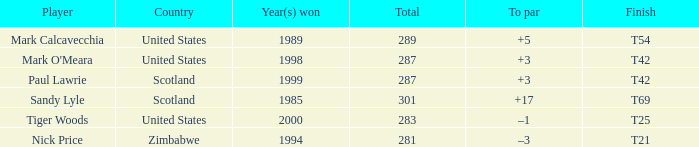What is Tiger Woods' to par? –1. 